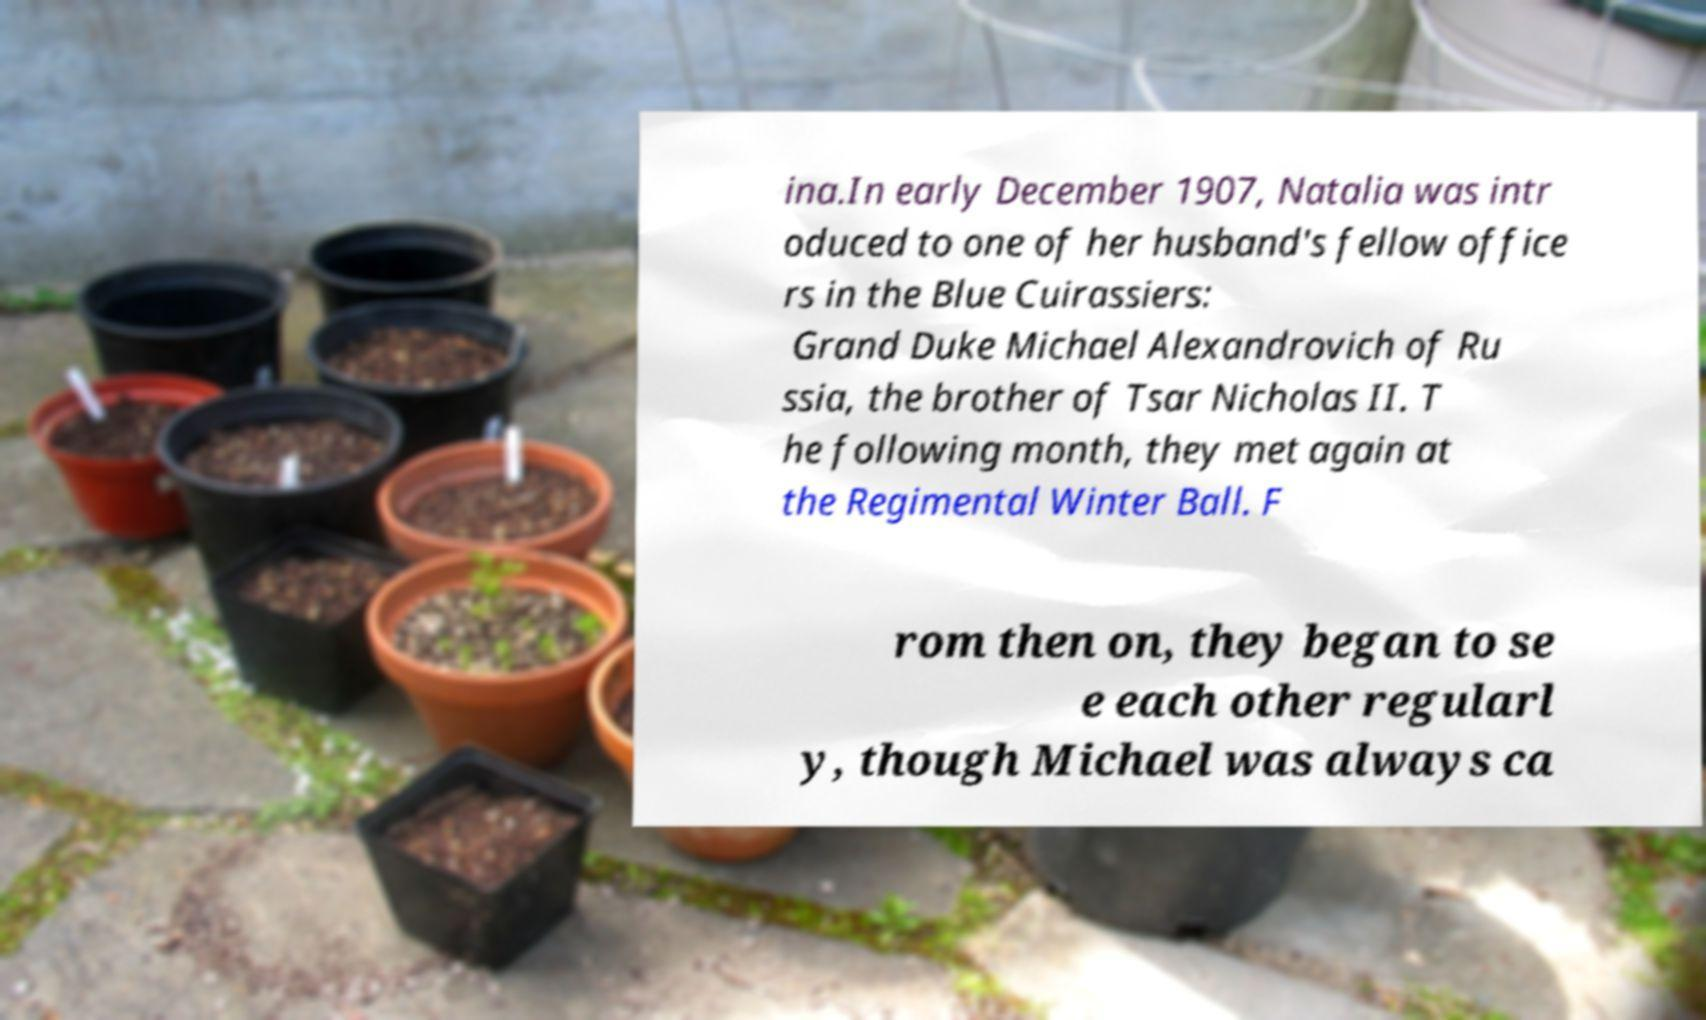Please identify and transcribe the text found in this image. ina.In early December 1907, Natalia was intr oduced to one of her husband's fellow office rs in the Blue Cuirassiers: Grand Duke Michael Alexandrovich of Ru ssia, the brother of Tsar Nicholas II. T he following month, they met again at the Regimental Winter Ball. F rom then on, they began to se e each other regularl y, though Michael was always ca 